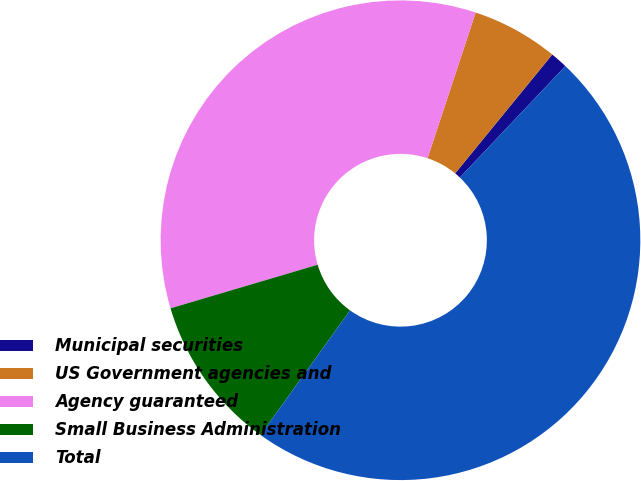Convert chart. <chart><loc_0><loc_0><loc_500><loc_500><pie_chart><fcel>Municipal securities<fcel>US Government agencies and<fcel>Agency guaranteed<fcel>Small Business Administration<fcel>Total<nl><fcel>1.16%<fcel>5.83%<fcel>34.65%<fcel>10.5%<fcel>47.85%<nl></chart> 